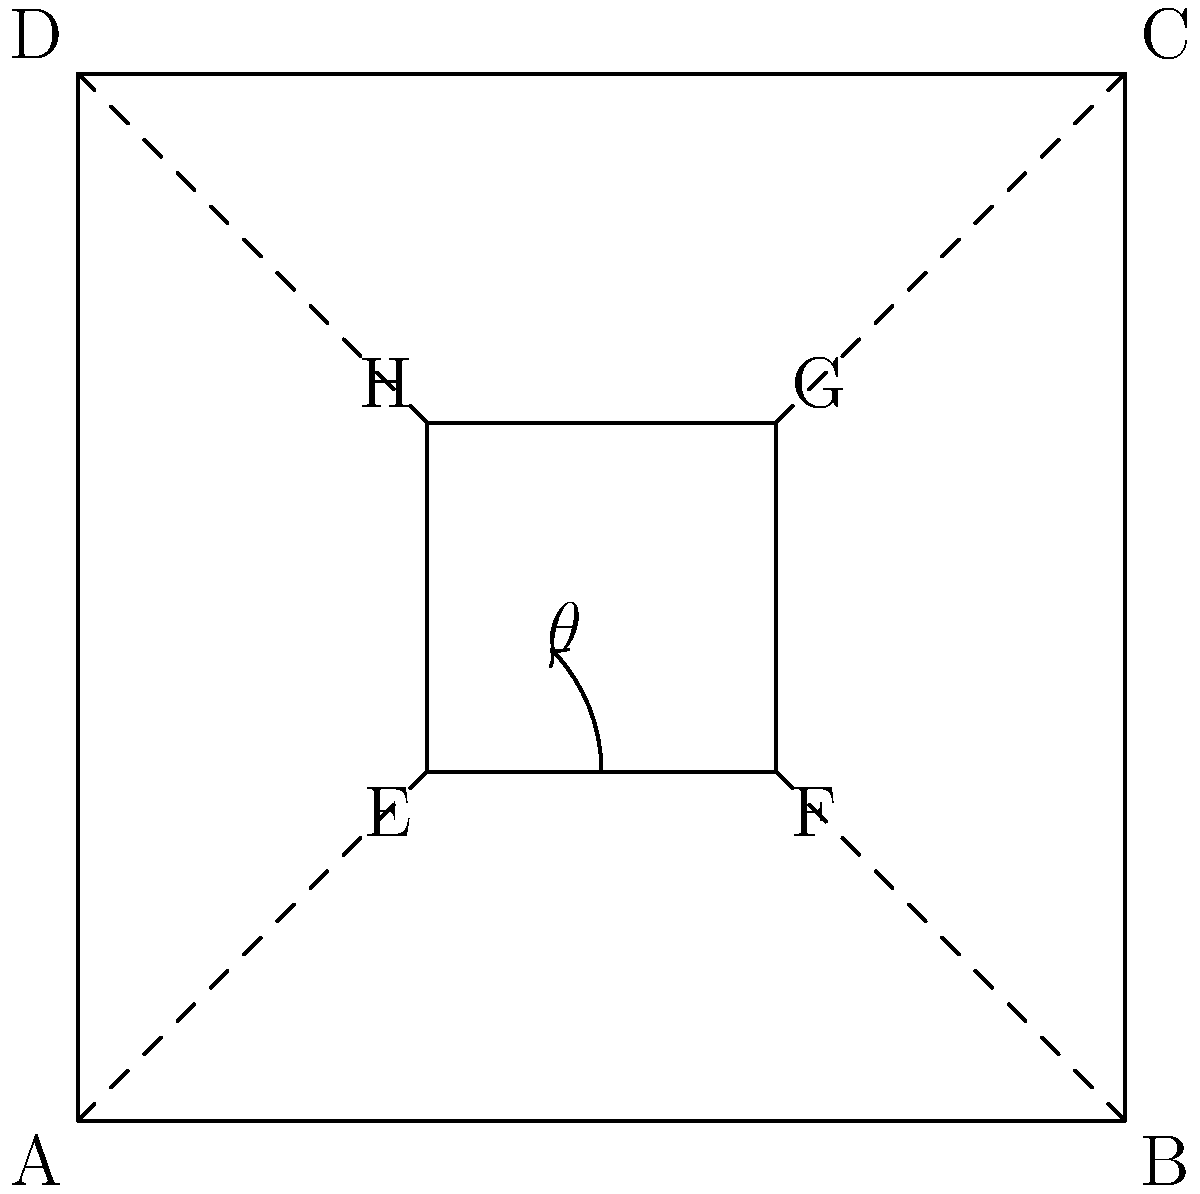In a cubist-inspired artwork, a square EFGH is rotated within a larger square ABCD. If the side length of ABCD is 3 units and the side length of EFGH is 1 unit, what is the angle of rotation ($\theta$) of EFGH in degrees? To find the angle of rotation, we can follow these steps:

1) First, let's identify the triangle formed by the rotation. We can see that triangle EAE' is formed, where E' is the original position of E before rotation.

2) In this triangle, we know:
   - AE = 1 (half the diagonal of the inner square)
   - AE' = 1 (distance from corner A to middle of side AD)

3) This forms an isosceles right triangle, where:
   $AE = AE' = 1$ and $EE' = \sqrt{2}$

4) In an isosceles right triangle, the two non-right angles are equal and each measure 45°.

5) The angle of rotation $\theta$ is one of these 45° angles.

Therefore, the angle of rotation of the inner square EFGH is 45°.
Answer: 45° 